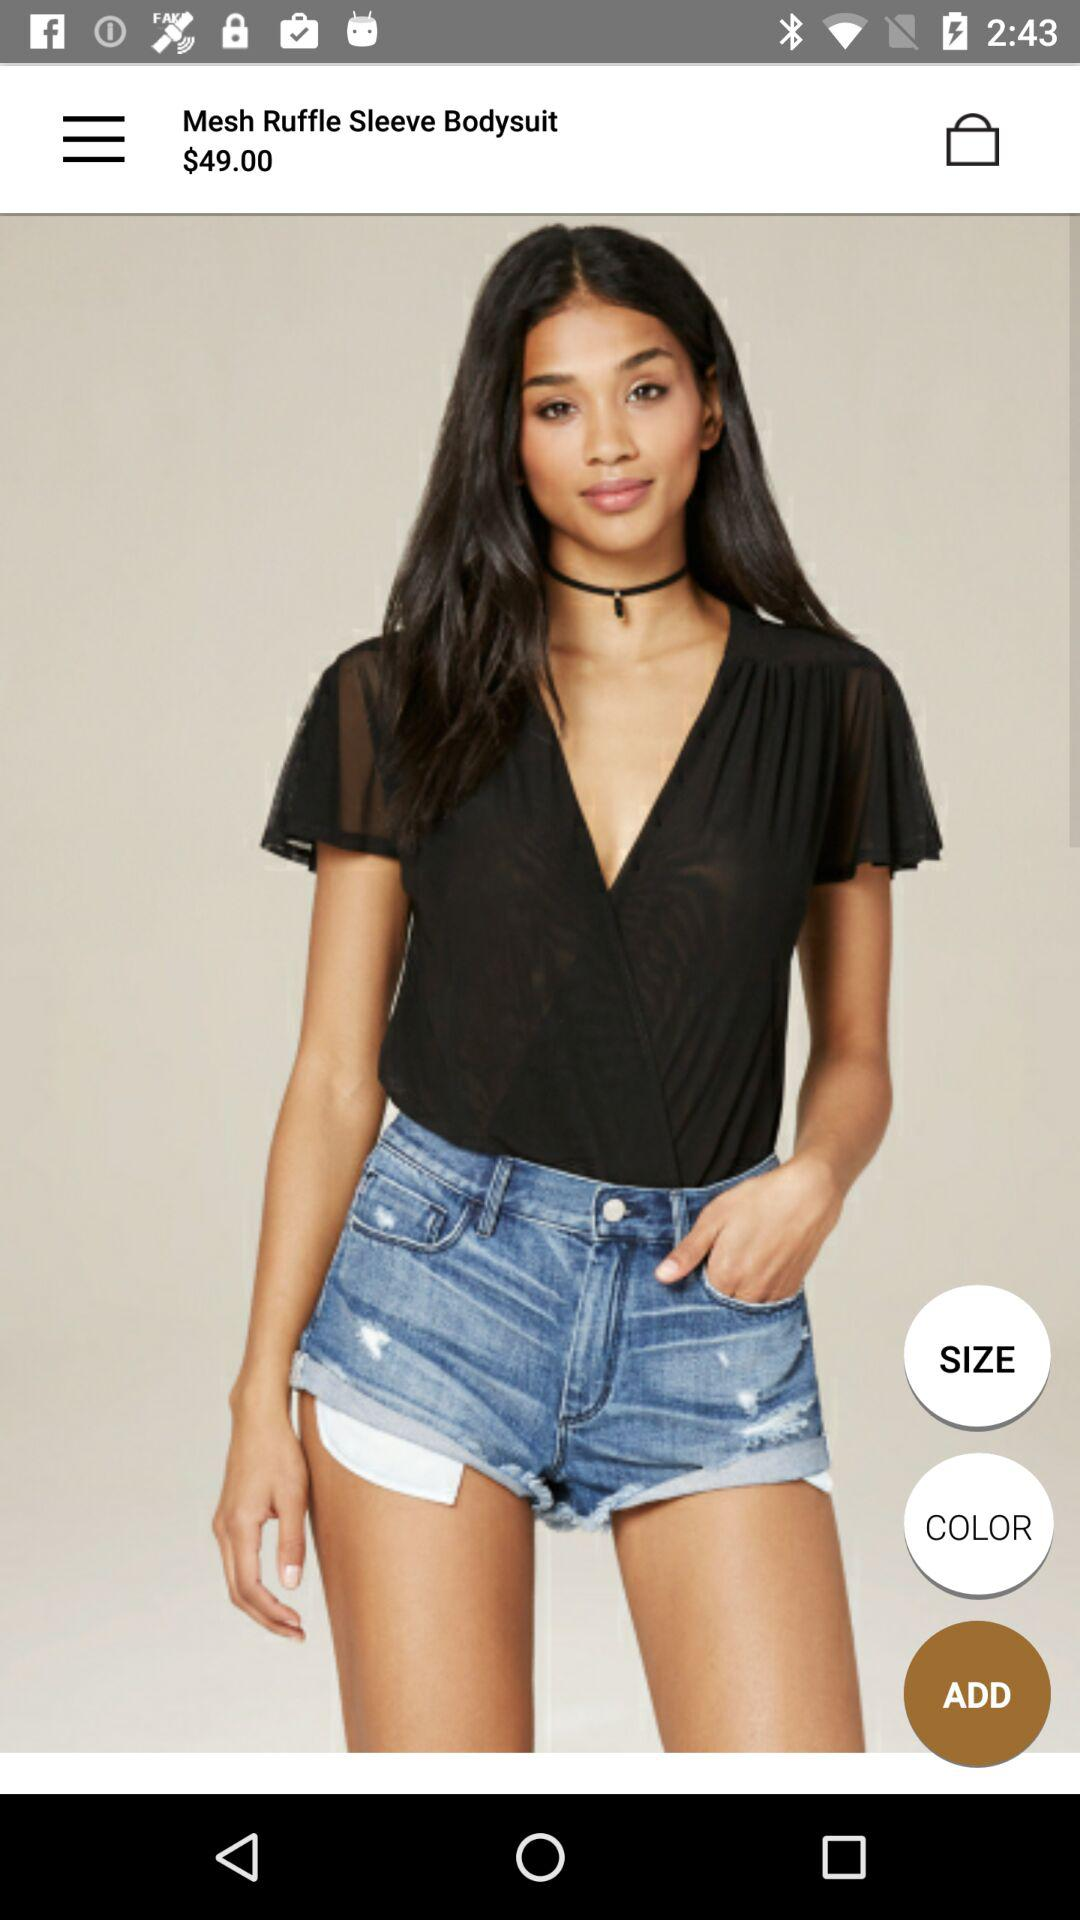How much is the product priced at?
Answer the question using a single word or phrase. $49.00 